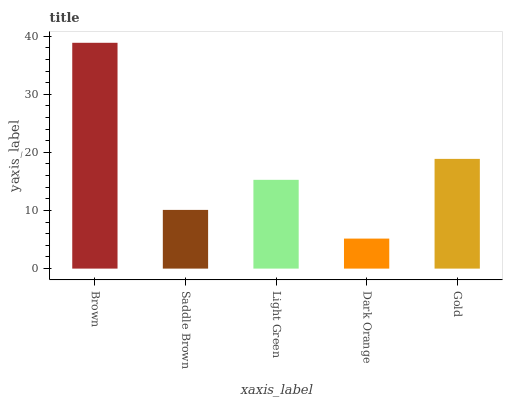Is Dark Orange the minimum?
Answer yes or no. Yes. Is Brown the maximum?
Answer yes or no. Yes. Is Saddle Brown the minimum?
Answer yes or no. No. Is Saddle Brown the maximum?
Answer yes or no. No. Is Brown greater than Saddle Brown?
Answer yes or no. Yes. Is Saddle Brown less than Brown?
Answer yes or no. Yes. Is Saddle Brown greater than Brown?
Answer yes or no. No. Is Brown less than Saddle Brown?
Answer yes or no. No. Is Light Green the high median?
Answer yes or no. Yes. Is Light Green the low median?
Answer yes or no. Yes. Is Saddle Brown the high median?
Answer yes or no. No. Is Gold the low median?
Answer yes or no. No. 